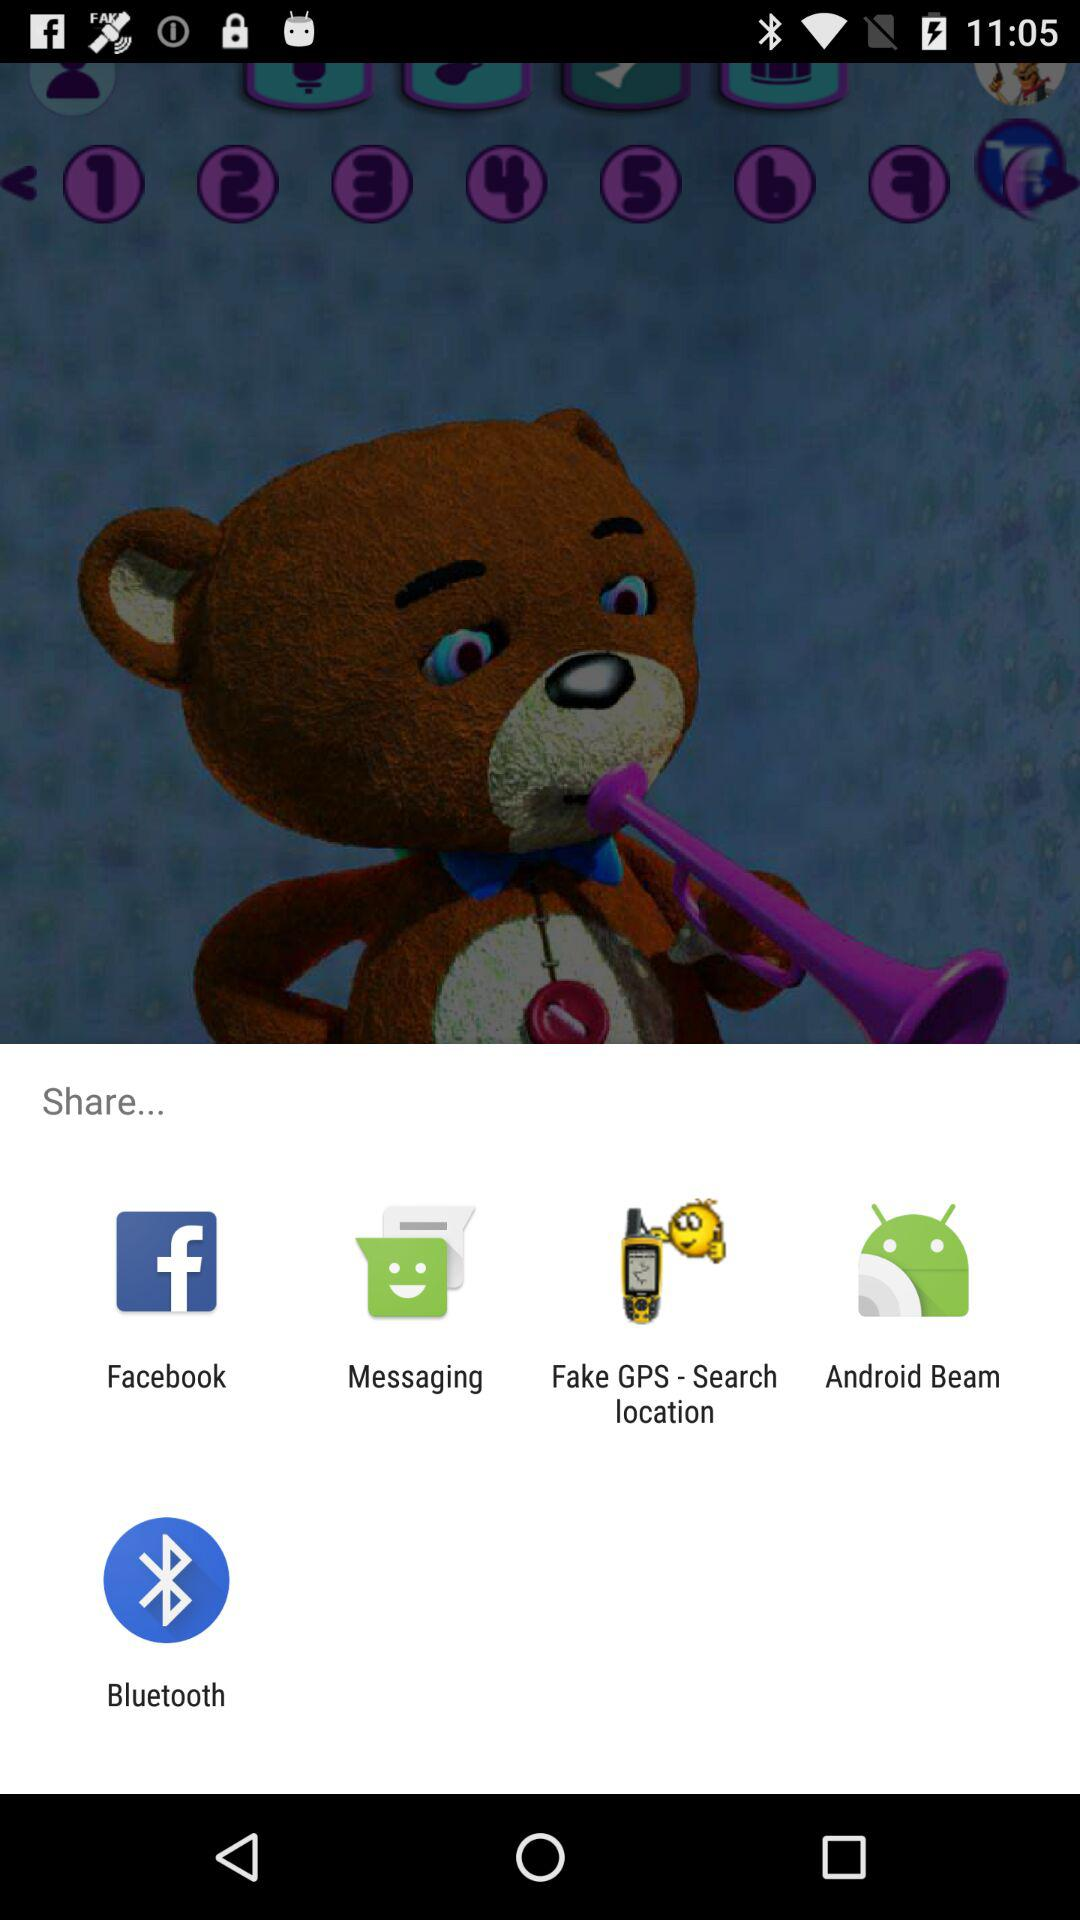Through what applications can we share? You can share it through "Facebook", "Messaging", "Fake GPS - Search location", "Android Beam", and "Bluetooth". 